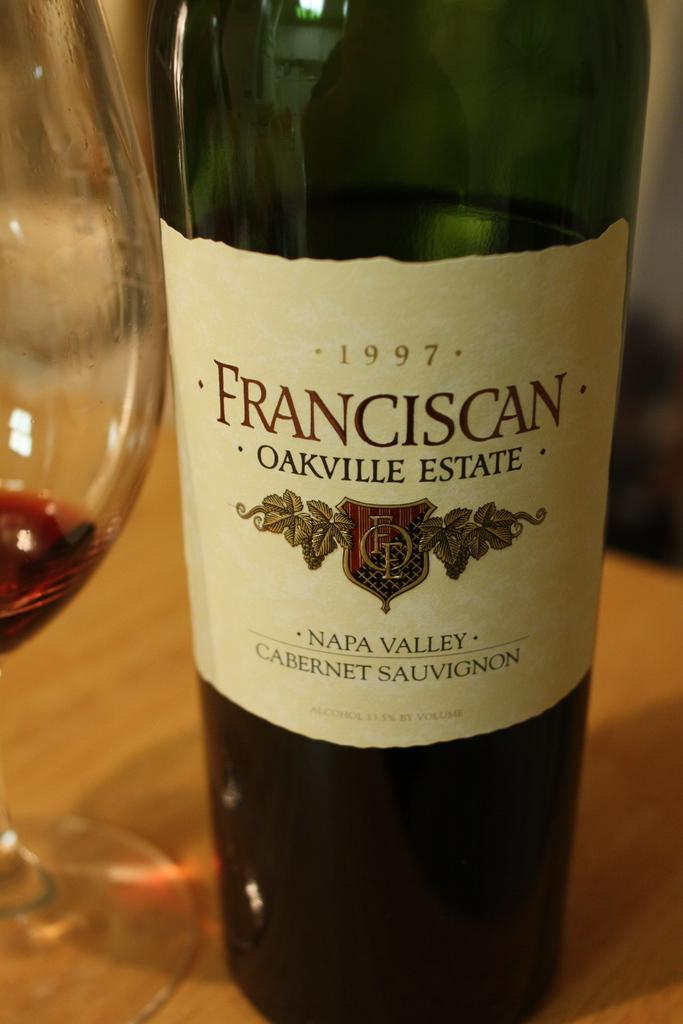What is present on the table in the image? There is a bottle and a glass on the table in the image. What can be used for drinking in the image? The glass can be used for drinking in the image. What is the other object on the table used for? The bottle is likely used for holding a liquid, such as water or juice. What type of letter is being written on the table in the image? A: There is no letter present in the image; it only shows a bottle and a glass on a table. How is the wool being used in the image? There is no wool present in the image. 